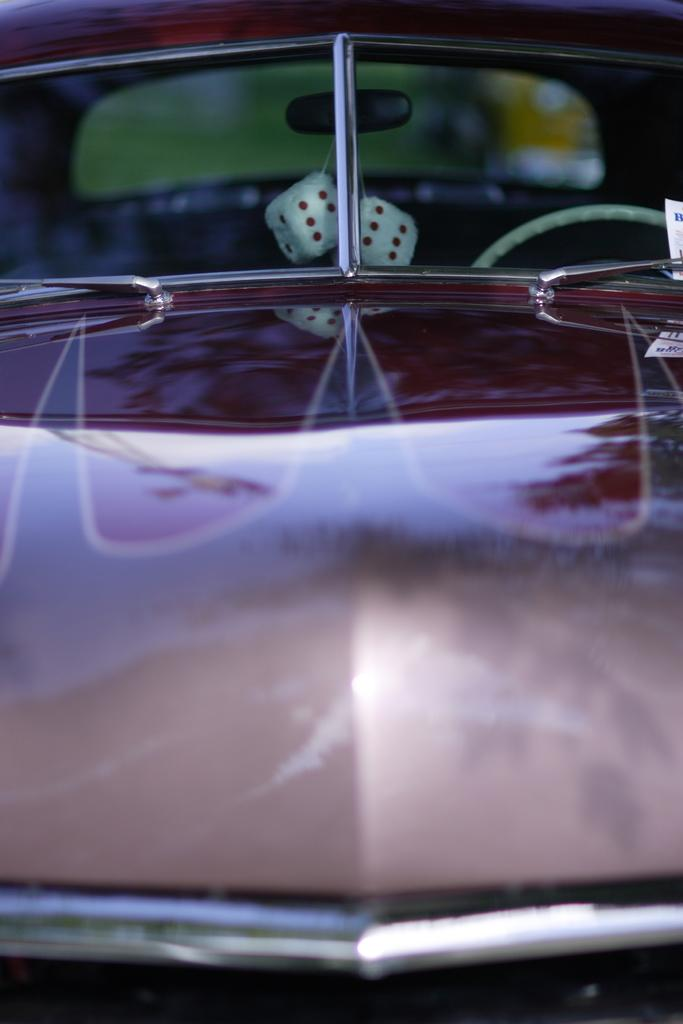What is the main subject of the image? The main subject of the image is a car. What is the car doing in the image? The car is moving towards the right in the image. What can be found inside the car? There is a steering wheel and a mirror inside the car. What is attached to the mirror? There are two objects hanging from the mirror. What is the color of the car? The car is brown in color. Can you tell me how much poison is stored in the cellar of the car in the image? There is no mention of poison or a cellar in the image, so it is not possible to determine if any poison is stored there. 